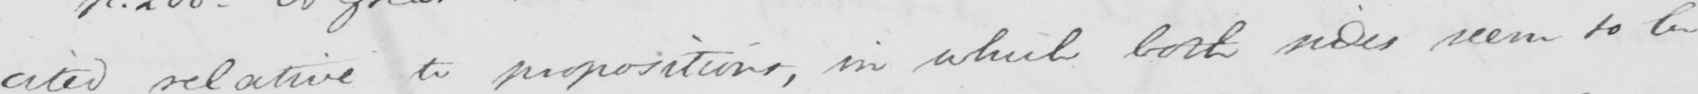What text is written in this handwritten line? cited relative to propositions , in which both sides seem to be 